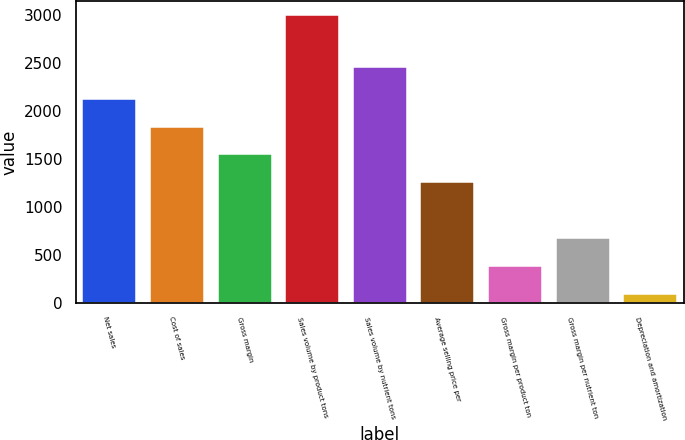Convert chart. <chart><loc_0><loc_0><loc_500><loc_500><bar_chart><fcel>Net sales<fcel>Cost of sales<fcel>Gross margin<fcel>Sales volume by product tons<fcel>Sales volume by nutrient tons<fcel>Average selling price per<fcel>Gross margin per product ton<fcel>Gross margin per nutrient ton<fcel>Depreciation and amortization<nl><fcel>2125.12<fcel>1835.16<fcel>1545.2<fcel>2995<fcel>2456<fcel>1255.24<fcel>385.36<fcel>675.32<fcel>95.4<nl></chart> 